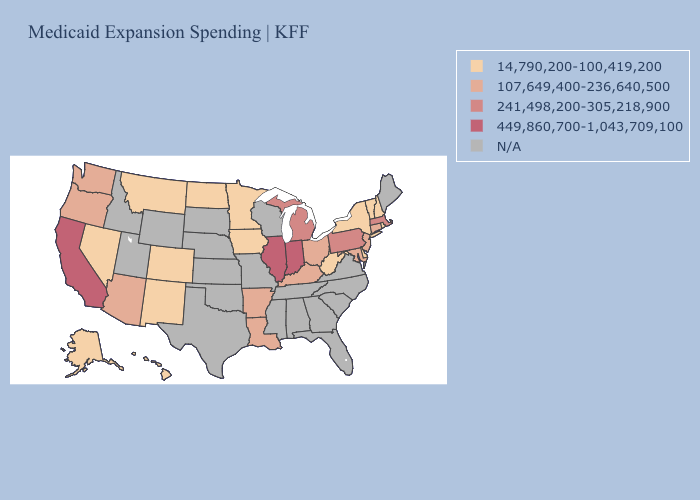Is the legend a continuous bar?
Short answer required. No. Among the states that border Wisconsin , does Michigan have the highest value?
Concise answer only. No. What is the value of Florida?
Keep it brief. N/A. Is the legend a continuous bar?
Keep it brief. No. Name the states that have a value in the range 14,790,200-100,419,200?
Give a very brief answer. Alaska, Colorado, Delaware, Hawaii, Iowa, Minnesota, Montana, Nevada, New Hampshire, New Mexico, New York, North Dakota, Rhode Island, Vermont, West Virginia. What is the value of Tennessee?
Short answer required. N/A. What is the value of Michigan?
Quick response, please. 241,498,200-305,218,900. What is the lowest value in the USA?
Keep it brief. 14,790,200-100,419,200. Name the states that have a value in the range 14,790,200-100,419,200?
Concise answer only. Alaska, Colorado, Delaware, Hawaii, Iowa, Minnesota, Montana, Nevada, New Hampshire, New Mexico, New York, North Dakota, Rhode Island, Vermont, West Virginia. Name the states that have a value in the range N/A?
Write a very short answer. Alabama, Florida, Georgia, Idaho, Kansas, Maine, Mississippi, Missouri, Nebraska, North Carolina, Oklahoma, South Carolina, South Dakota, Tennessee, Texas, Utah, Virginia, Wisconsin, Wyoming. Name the states that have a value in the range 14,790,200-100,419,200?
Keep it brief. Alaska, Colorado, Delaware, Hawaii, Iowa, Minnesota, Montana, Nevada, New Hampshire, New Mexico, New York, North Dakota, Rhode Island, Vermont, West Virginia. Name the states that have a value in the range N/A?
Write a very short answer. Alabama, Florida, Georgia, Idaho, Kansas, Maine, Mississippi, Missouri, Nebraska, North Carolina, Oklahoma, South Carolina, South Dakota, Tennessee, Texas, Utah, Virginia, Wisconsin, Wyoming. Name the states that have a value in the range 241,498,200-305,218,900?
Quick response, please. Massachusetts, Michigan, Pennsylvania. Among the states that border Wyoming , which have the highest value?
Short answer required. Colorado, Montana. 